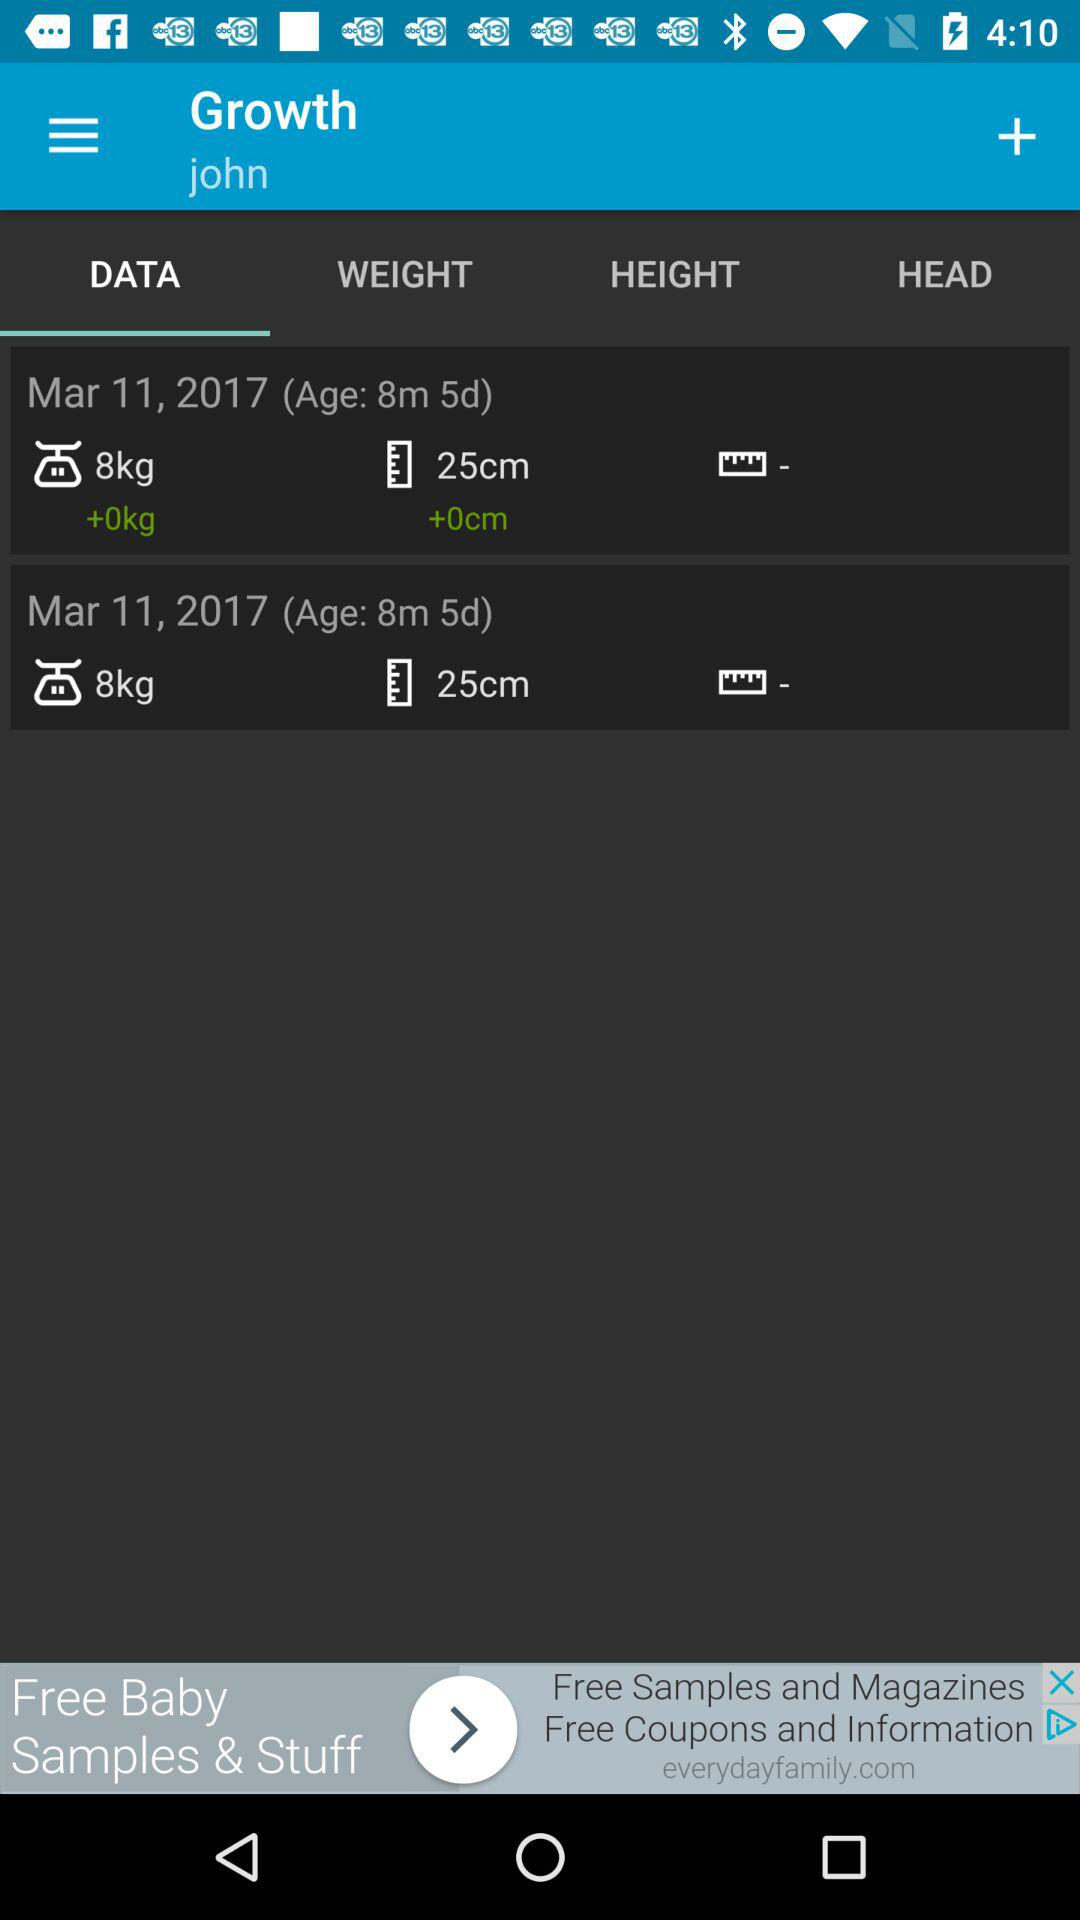What was the weight on March 11, 2017? The weight is 8 kg. 